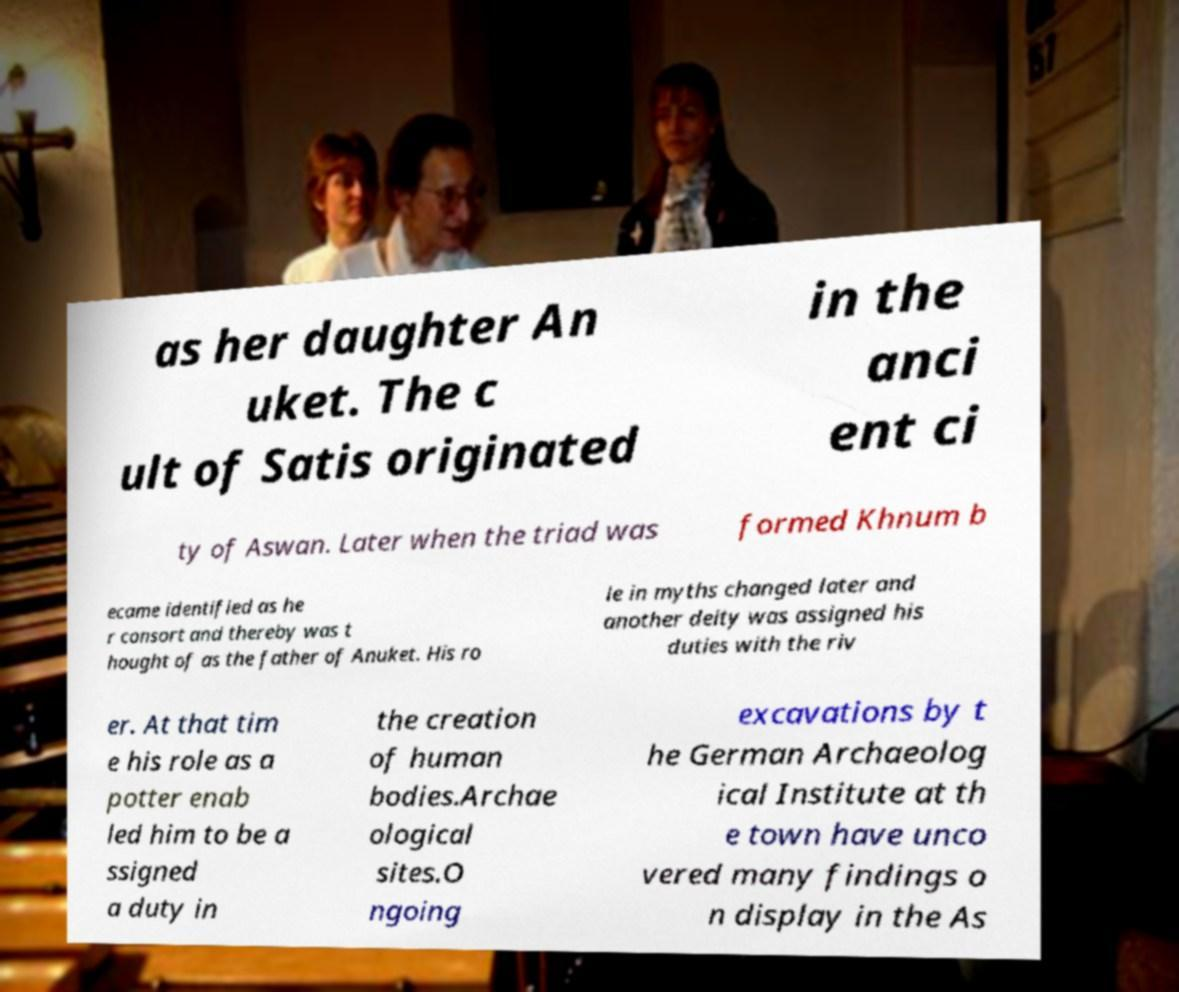There's text embedded in this image that I need extracted. Can you transcribe it verbatim? as her daughter An uket. The c ult of Satis originated in the anci ent ci ty of Aswan. Later when the triad was formed Khnum b ecame identified as he r consort and thereby was t hought of as the father of Anuket. His ro le in myths changed later and another deity was assigned his duties with the riv er. At that tim e his role as a potter enab led him to be a ssigned a duty in the creation of human bodies.Archae ological sites.O ngoing excavations by t he German Archaeolog ical Institute at th e town have unco vered many findings o n display in the As 